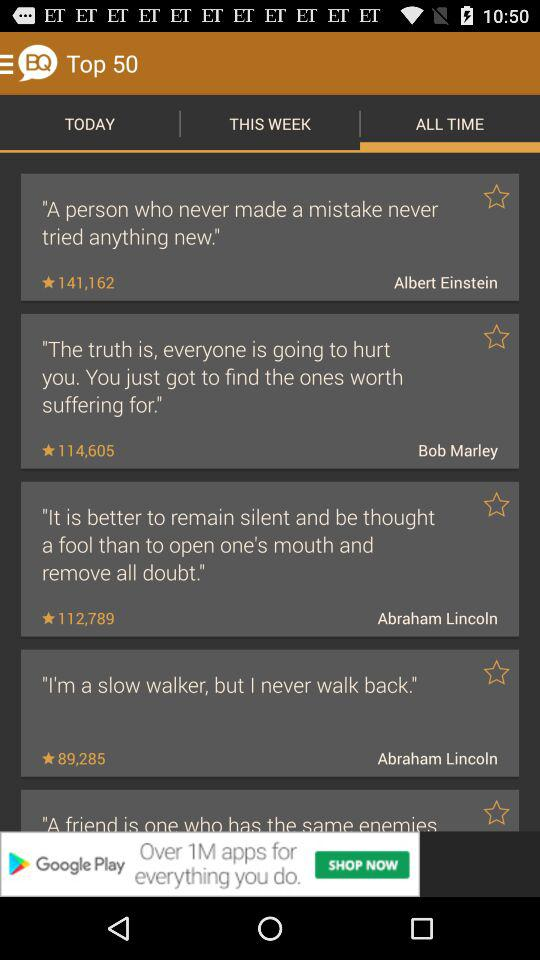How many quotes are there in total?
Answer the question using a single word or phrase. 5 